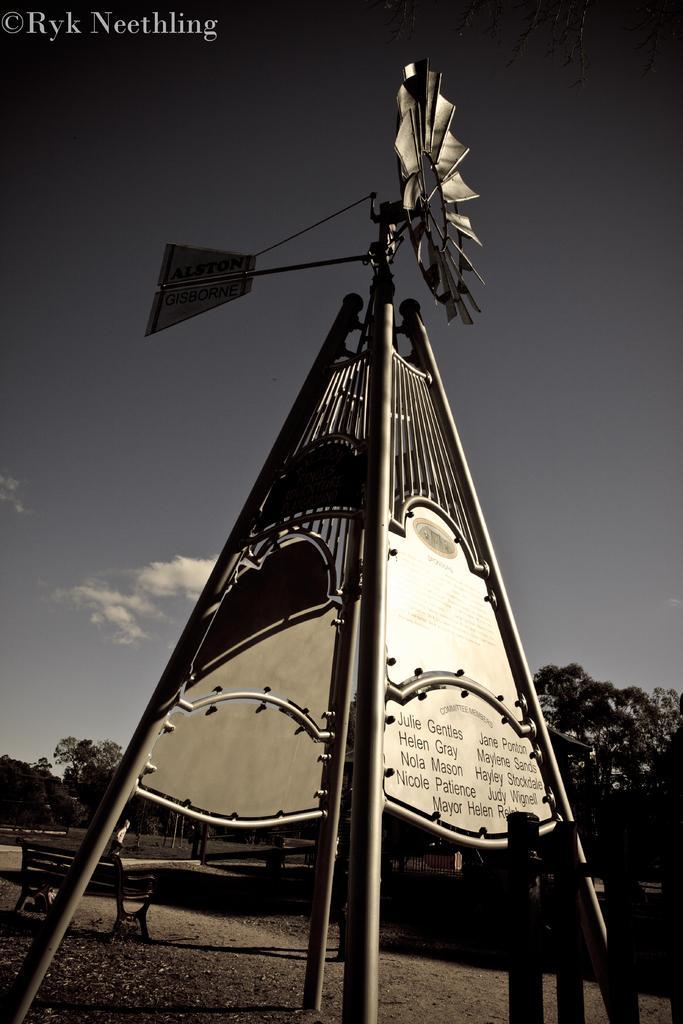Can you describe this image briefly? This image is taken outdoors. At the top of the image there is the sky with clouds. In the background there are a few trees. There are a few poles. There is a fence. There is an empty bench. In the middle of the image there is an architecture with iron bars and grills. There are two boards with text on them. There is an object, it seems to be a fan. At the bottom of the image there is a ground. 